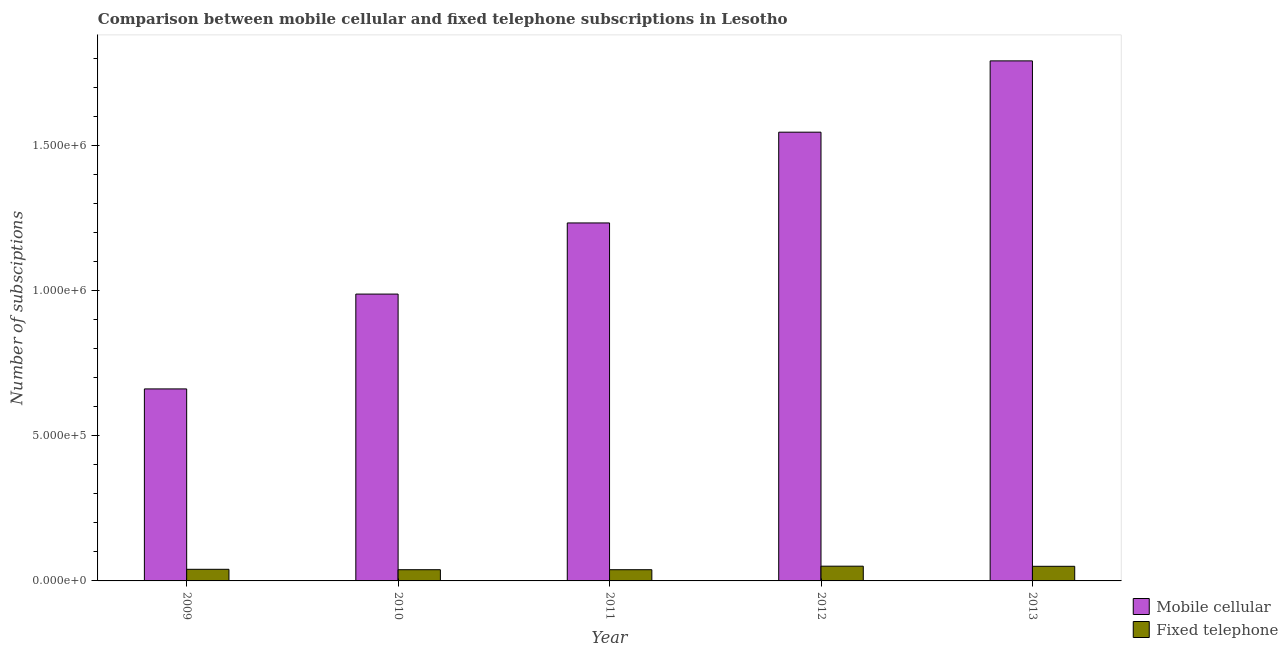How many different coloured bars are there?
Your answer should be very brief. 2. How many groups of bars are there?
Offer a very short reply. 5. How many bars are there on the 4th tick from the left?
Offer a terse response. 2. How many bars are there on the 5th tick from the right?
Provide a succinct answer. 2. What is the label of the 2nd group of bars from the left?
Provide a short and direct response. 2010. In how many cases, is the number of bars for a given year not equal to the number of legend labels?
Provide a succinct answer. 0. What is the number of mobile cellular subscriptions in 2012?
Ensure brevity in your answer.  1.54e+06. Across all years, what is the maximum number of mobile cellular subscriptions?
Make the answer very short. 1.79e+06. Across all years, what is the minimum number of mobile cellular subscriptions?
Provide a short and direct response. 6.61e+05. What is the total number of mobile cellular subscriptions in the graph?
Your answer should be compact. 6.22e+06. What is the difference between the number of mobile cellular subscriptions in 2011 and that in 2012?
Your response must be concise. -3.12e+05. What is the difference between the number of mobile cellular subscriptions in 2011 and the number of fixed telephone subscriptions in 2010?
Make the answer very short. 2.45e+05. What is the average number of mobile cellular subscriptions per year?
Your answer should be compact. 1.24e+06. What is the ratio of the number of mobile cellular subscriptions in 2009 to that in 2012?
Offer a terse response. 0.43. Is the number of fixed telephone subscriptions in 2011 less than that in 2012?
Keep it short and to the point. Yes. Is the difference between the number of mobile cellular subscriptions in 2010 and 2011 greater than the difference between the number of fixed telephone subscriptions in 2010 and 2011?
Keep it short and to the point. No. What is the difference between the highest and the second highest number of mobile cellular subscriptions?
Ensure brevity in your answer.  2.45e+05. What is the difference between the highest and the lowest number of fixed telephone subscriptions?
Provide a short and direct response. 1.22e+04. What does the 1st bar from the left in 2012 represents?
Give a very brief answer. Mobile cellular. What does the 2nd bar from the right in 2010 represents?
Offer a very short reply. Mobile cellular. How many bars are there?
Offer a terse response. 10. Are the values on the major ticks of Y-axis written in scientific E-notation?
Offer a terse response. Yes. How many legend labels are there?
Make the answer very short. 2. How are the legend labels stacked?
Keep it short and to the point. Vertical. What is the title of the graph?
Keep it short and to the point. Comparison between mobile cellular and fixed telephone subscriptions in Lesotho. Does "Age 65(female)" appear as one of the legend labels in the graph?
Give a very brief answer. No. What is the label or title of the X-axis?
Provide a succinct answer. Year. What is the label or title of the Y-axis?
Keep it short and to the point. Number of subsciptions. What is the Number of subsciptions of Mobile cellular in 2009?
Offer a very short reply. 6.61e+05. What is the Number of subsciptions of Mobile cellular in 2010?
Ensure brevity in your answer.  9.87e+05. What is the Number of subsciptions in Fixed telephone in 2010?
Your response must be concise. 3.86e+04. What is the Number of subsciptions of Mobile cellular in 2011?
Give a very brief answer. 1.23e+06. What is the Number of subsciptions of Fixed telephone in 2011?
Offer a terse response. 3.86e+04. What is the Number of subsciptions of Mobile cellular in 2012?
Your answer should be compact. 1.54e+06. What is the Number of subsciptions in Fixed telephone in 2012?
Keep it short and to the point. 5.08e+04. What is the Number of subsciptions of Mobile cellular in 2013?
Provide a succinct answer. 1.79e+06. What is the Number of subsciptions in Fixed telephone in 2013?
Keep it short and to the point. 5.03e+04. Across all years, what is the maximum Number of subsciptions of Mobile cellular?
Make the answer very short. 1.79e+06. Across all years, what is the maximum Number of subsciptions in Fixed telephone?
Offer a very short reply. 5.08e+04. Across all years, what is the minimum Number of subsciptions of Mobile cellular?
Provide a succinct answer. 6.61e+05. Across all years, what is the minimum Number of subsciptions in Fixed telephone?
Ensure brevity in your answer.  3.86e+04. What is the total Number of subsciptions of Mobile cellular in the graph?
Keep it short and to the point. 6.22e+06. What is the total Number of subsciptions in Fixed telephone in the graph?
Your response must be concise. 2.18e+05. What is the difference between the Number of subsciptions of Mobile cellular in 2009 and that in 2010?
Ensure brevity in your answer.  -3.26e+05. What is the difference between the Number of subsciptions in Fixed telephone in 2009 and that in 2010?
Make the answer very short. 1388. What is the difference between the Number of subsciptions in Mobile cellular in 2009 and that in 2011?
Keep it short and to the point. -5.71e+05. What is the difference between the Number of subsciptions of Fixed telephone in 2009 and that in 2011?
Ensure brevity in your answer.  1421. What is the difference between the Number of subsciptions in Mobile cellular in 2009 and that in 2012?
Your response must be concise. -8.84e+05. What is the difference between the Number of subsciptions of Fixed telephone in 2009 and that in 2012?
Your answer should be very brief. -1.08e+04. What is the difference between the Number of subsciptions in Mobile cellular in 2009 and that in 2013?
Offer a terse response. -1.13e+06. What is the difference between the Number of subsciptions of Fixed telephone in 2009 and that in 2013?
Make the answer very short. -1.03e+04. What is the difference between the Number of subsciptions of Mobile cellular in 2010 and that in 2011?
Ensure brevity in your answer.  -2.45e+05. What is the difference between the Number of subsciptions in Mobile cellular in 2010 and that in 2012?
Your answer should be very brief. -5.57e+05. What is the difference between the Number of subsciptions of Fixed telephone in 2010 and that in 2012?
Your response must be concise. -1.22e+04. What is the difference between the Number of subsciptions in Mobile cellular in 2010 and that in 2013?
Your answer should be very brief. -8.03e+05. What is the difference between the Number of subsciptions in Fixed telephone in 2010 and that in 2013?
Your answer should be compact. -1.17e+04. What is the difference between the Number of subsciptions in Mobile cellular in 2011 and that in 2012?
Provide a succinct answer. -3.12e+05. What is the difference between the Number of subsciptions of Fixed telephone in 2011 and that in 2012?
Your answer should be compact. -1.22e+04. What is the difference between the Number of subsciptions of Mobile cellular in 2011 and that in 2013?
Give a very brief answer. -5.58e+05. What is the difference between the Number of subsciptions in Fixed telephone in 2011 and that in 2013?
Your answer should be compact. -1.18e+04. What is the difference between the Number of subsciptions of Mobile cellular in 2012 and that in 2013?
Your answer should be very brief. -2.45e+05. What is the difference between the Number of subsciptions in Fixed telephone in 2012 and that in 2013?
Your response must be concise. 424. What is the difference between the Number of subsciptions of Mobile cellular in 2009 and the Number of subsciptions of Fixed telephone in 2010?
Provide a succinct answer. 6.22e+05. What is the difference between the Number of subsciptions in Mobile cellular in 2009 and the Number of subsciptions in Fixed telephone in 2011?
Offer a terse response. 6.22e+05. What is the difference between the Number of subsciptions in Mobile cellular in 2009 and the Number of subsciptions in Fixed telephone in 2012?
Your answer should be very brief. 6.10e+05. What is the difference between the Number of subsciptions in Mobile cellular in 2009 and the Number of subsciptions in Fixed telephone in 2013?
Provide a short and direct response. 6.11e+05. What is the difference between the Number of subsciptions of Mobile cellular in 2010 and the Number of subsciptions of Fixed telephone in 2011?
Ensure brevity in your answer.  9.49e+05. What is the difference between the Number of subsciptions in Mobile cellular in 2010 and the Number of subsciptions in Fixed telephone in 2012?
Make the answer very short. 9.37e+05. What is the difference between the Number of subsciptions in Mobile cellular in 2010 and the Number of subsciptions in Fixed telephone in 2013?
Make the answer very short. 9.37e+05. What is the difference between the Number of subsciptions of Mobile cellular in 2011 and the Number of subsciptions of Fixed telephone in 2012?
Your answer should be compact. 1.18e+06. What is the difference between the Number of subsciptions of Mobile cellular in 2011 and the Number of subsciptions of Fixed telephone in 2013?
Make the answer very short. 1.18e+06. What is the difference between the Number of subsciptions in Mobile cellular in 2012 and the Number of subsciptions in Fixed telephone in 2013?
Make the answer very short. 1.49e+06. What is the average Number of subsciptions in Mobile cellular per year?
Ensure brevity in your answer.  1.24e+06. What is the average Number of subsciptions of Fixed telephone per year?
Offer a very short reply. 4.37e+04. In the year 2009, what is the difference between the Number of subsciptions of Mobile cellular and Number of subsciptions of Fixed telephone?
Your answer should be very brief. 6.21e+05. In the year 2010, what is the difference between the Number of subsciptions of Mobile cellular and Number of subsciptions of Fixed telephone?
Offer a very short reply. 9.49e+05. In the year 2011, what is the difference between the Number of subsciptions in Mobile cellular and Number of subsciptions in Fixed telephone?
Ensure brevity in your answer.  1.19e+06. In the year 2012, what is the difference between the Number of subsciptions of Mobile cellular and Number of subsciptions of Fixed telephone?
Provide a succinct answer. 1.49e+06. In the year 2013, what is the difference between the Number of subsciptions of Mobile cellular and Number of subsciptions of Fixed telephone?
Provide a succinct answer. 1.74e+06. What is the ratio of the Number of subsciptions in Mobile cellular in 2009 to that in 2010?
Your answer should be very brief. 0.67. What is the ratio of the Number of subsciptions in Fixed telephone in 2009 to that in 2010?
Provide a succinct answer. 1.04. What is the ratio of the Number of subsciptions of Mobile cellular in 2009 to that in 2011?
Make the answer very short. 0.54. What is the ratio of the Number of subsciptions of Fixed telephone in 2009 to that in 2011?
Give a very brief answer. 1.04. What is the ratio of the Number of subsciptions of Mobile cellular in 2009 to that in 2012?
Provide a short and direct response. 0.43. What is the ratio of the Number of subsciptions in Fixed telephone in 2009 to that in 2012?
Ensure brevity in your answer.  0.79. What is the ratio of the Number of subsciptions in Mobile cellular in 2009 to that in 2013?
Keep it short and to the point. 0.37. What is the ratio of the Number of subsciptions of Fixed telephone in 2009 to that in 2013?
Provide a short and direct response. 0.79. What is the ratio of the Number of subsciptions of Mobile cellular in 2010 to that in 2011?
Your response must be concise. 0.8. What is the ratio of the Number of subsciptions of Mobile cellular in 2010 to that in 2012?
Provide a succinct answer. 0.64. What is the ratio of the Number of subsciptions of Fixed telephone in 2010 to that in 2012?
Provide a short and direct response. 0.76. What is the ratio of the Number of subsciptions in Mobile cellular in 2010 to that in 2013?
Provide a short and direct response. 0.55. What is the ratio of the Number of subsciptions of Fixed telephone in 2010 to that in 2013?
Offer a terse response. 0.77. What is the ratio of the Number of subsciptions of Mobile cellular in 2011 to that in 2012?
Offer a terse response. 0.8. What is the ratio of the Number of subsciptions in Fixed telephone in 2011 to that in 2012?
Offer a very short reply. 0.76. What is the ratio of the Number of subsciptions of Mobile cellular in 2011 to that in 2013?
Your response must be concise. 0.69. What is the ratio of the Number of subsciptions in Fixed telephone in 2011 to that in 2013?
Your answer should be compact. 0.77. What is the ratio of the Number of subsciptions of Mobile cellular in 2012 to that in 2013?
Your answer should be compact. 0.86. What is the ratio of the Number of subsciptions of Fixed telephone in 2012 to that in 2013?
Offer a terse response. 1.01. What is the difference between the highest and the second highest Number of subsciptions of Mobile cellular?
Offer a terse response. 2.45e+05. What is the difference between the highest and the second highest Number of subsciptions of Fixed telephone?
Provide a short and direct response. 424. What is the difference between the highest and the lowest Number of subsciptions of Mobile cellular?
Keep it short and to the point. 1.13e+06. What is the difference between the highest and the lowest Number of subsciptions of Fixed telephone?
Provide a succinct answer. 1.22e+04. 